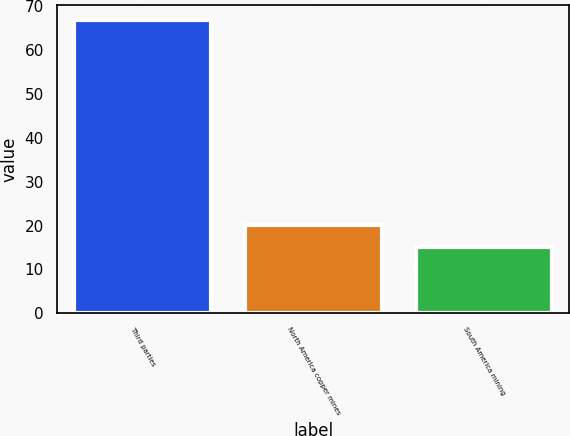Convert chart to OTSL. <chart><loc_0><loc_0><loc_500><loc_500><bar_chart><fcel>Third parties<fcel>North America copper mines<fcel>South America mining<nl><fcel>67<fcel>20.2<fcel>15<nl></chart> 